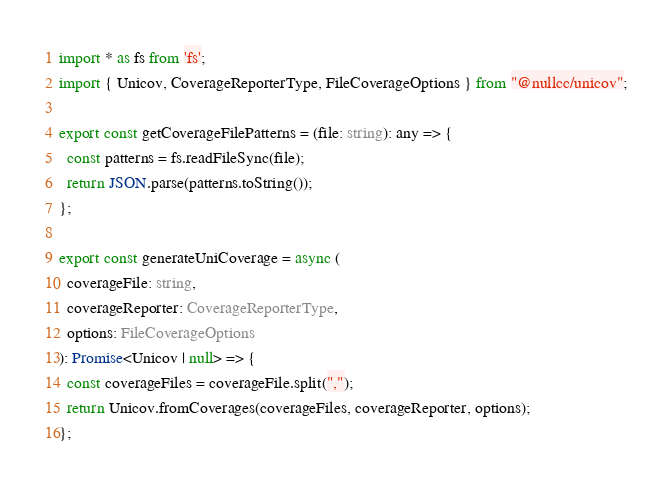Convert code to text. <code><loc_0><loc_0><loc_500><loc_500><_TypeScript_>import * as fs from 'fs';
import { Unicov, CoverageReporterType, FileCoverageOptions } from "@nullcc/unicov";

export const getCoverageFilePatterns = (file: string): any => {
  const patterns = fs.readFileSync(file);
  return JSON.parse(patterns.toString());
};

export const generateUniCoverage = async (
  coverageFile: string,
  coverageReporter: CoverageReporterType,
  options: FileCoverageOptions
): Promise<Unicov | null> => {
  const coverageFiles = coverageFile.split(",");
  return Unicov.fromCoverages(coverageFiles, coverageReporter, options);
};
</code> 